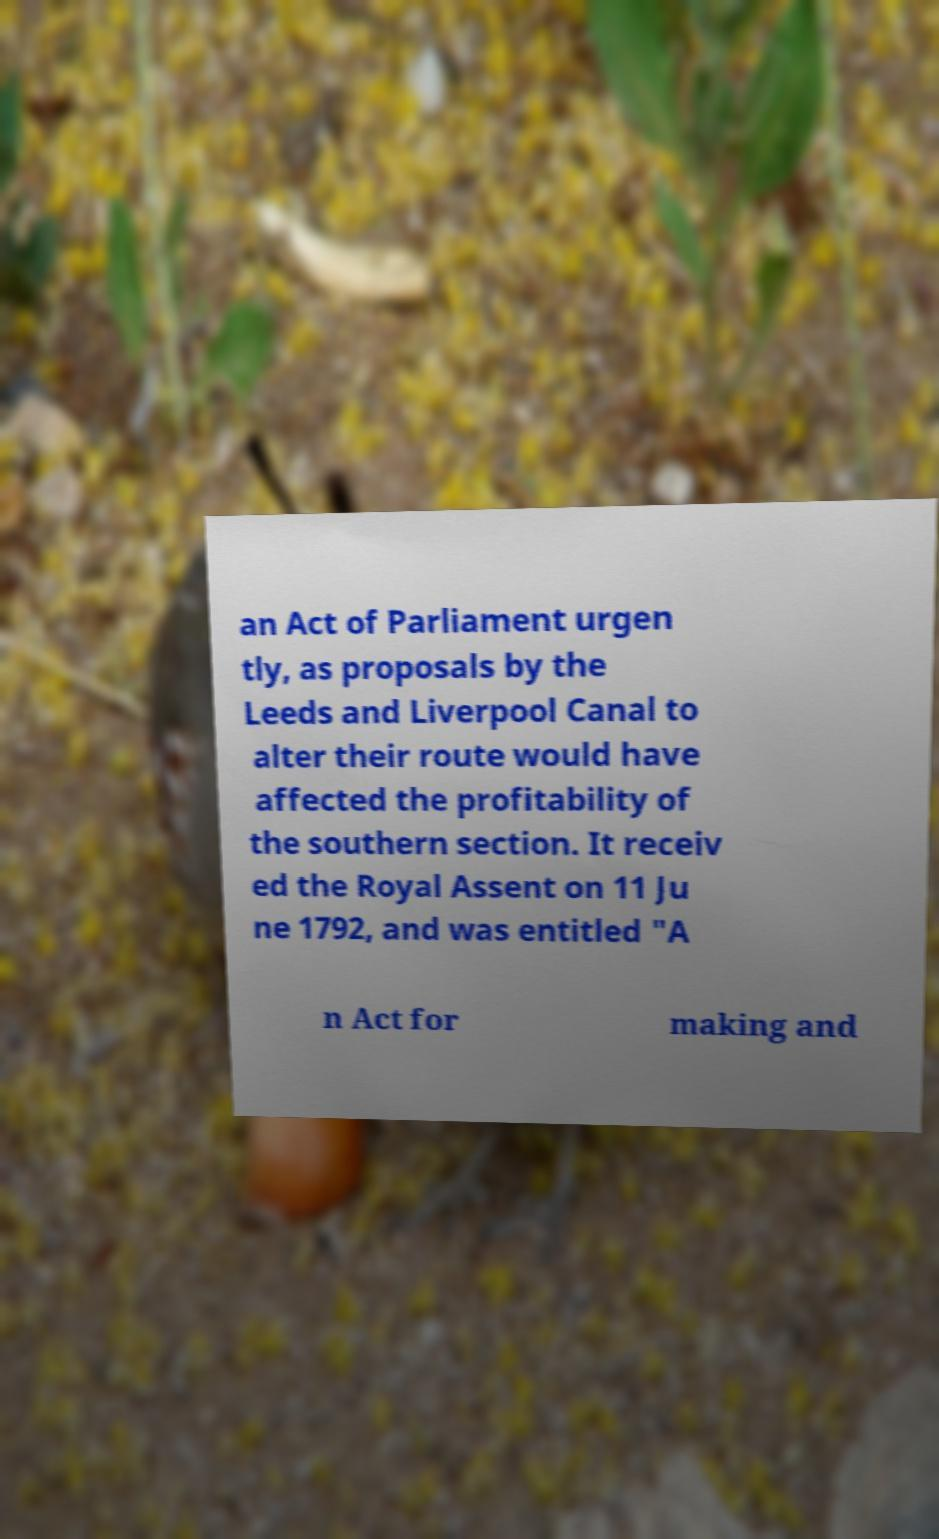There's text embedded in this image that I need extracted. Can you transcribe it verbatim? an Act of Parliament urgen tly, as proposals by the Leeds and Liverpool Canal to alter their route would have affected the profitability of the southern section. It receiv ed the Royal Assent on 11 Ju ne 1792, and was entitled "A n Act for making and 